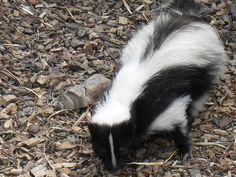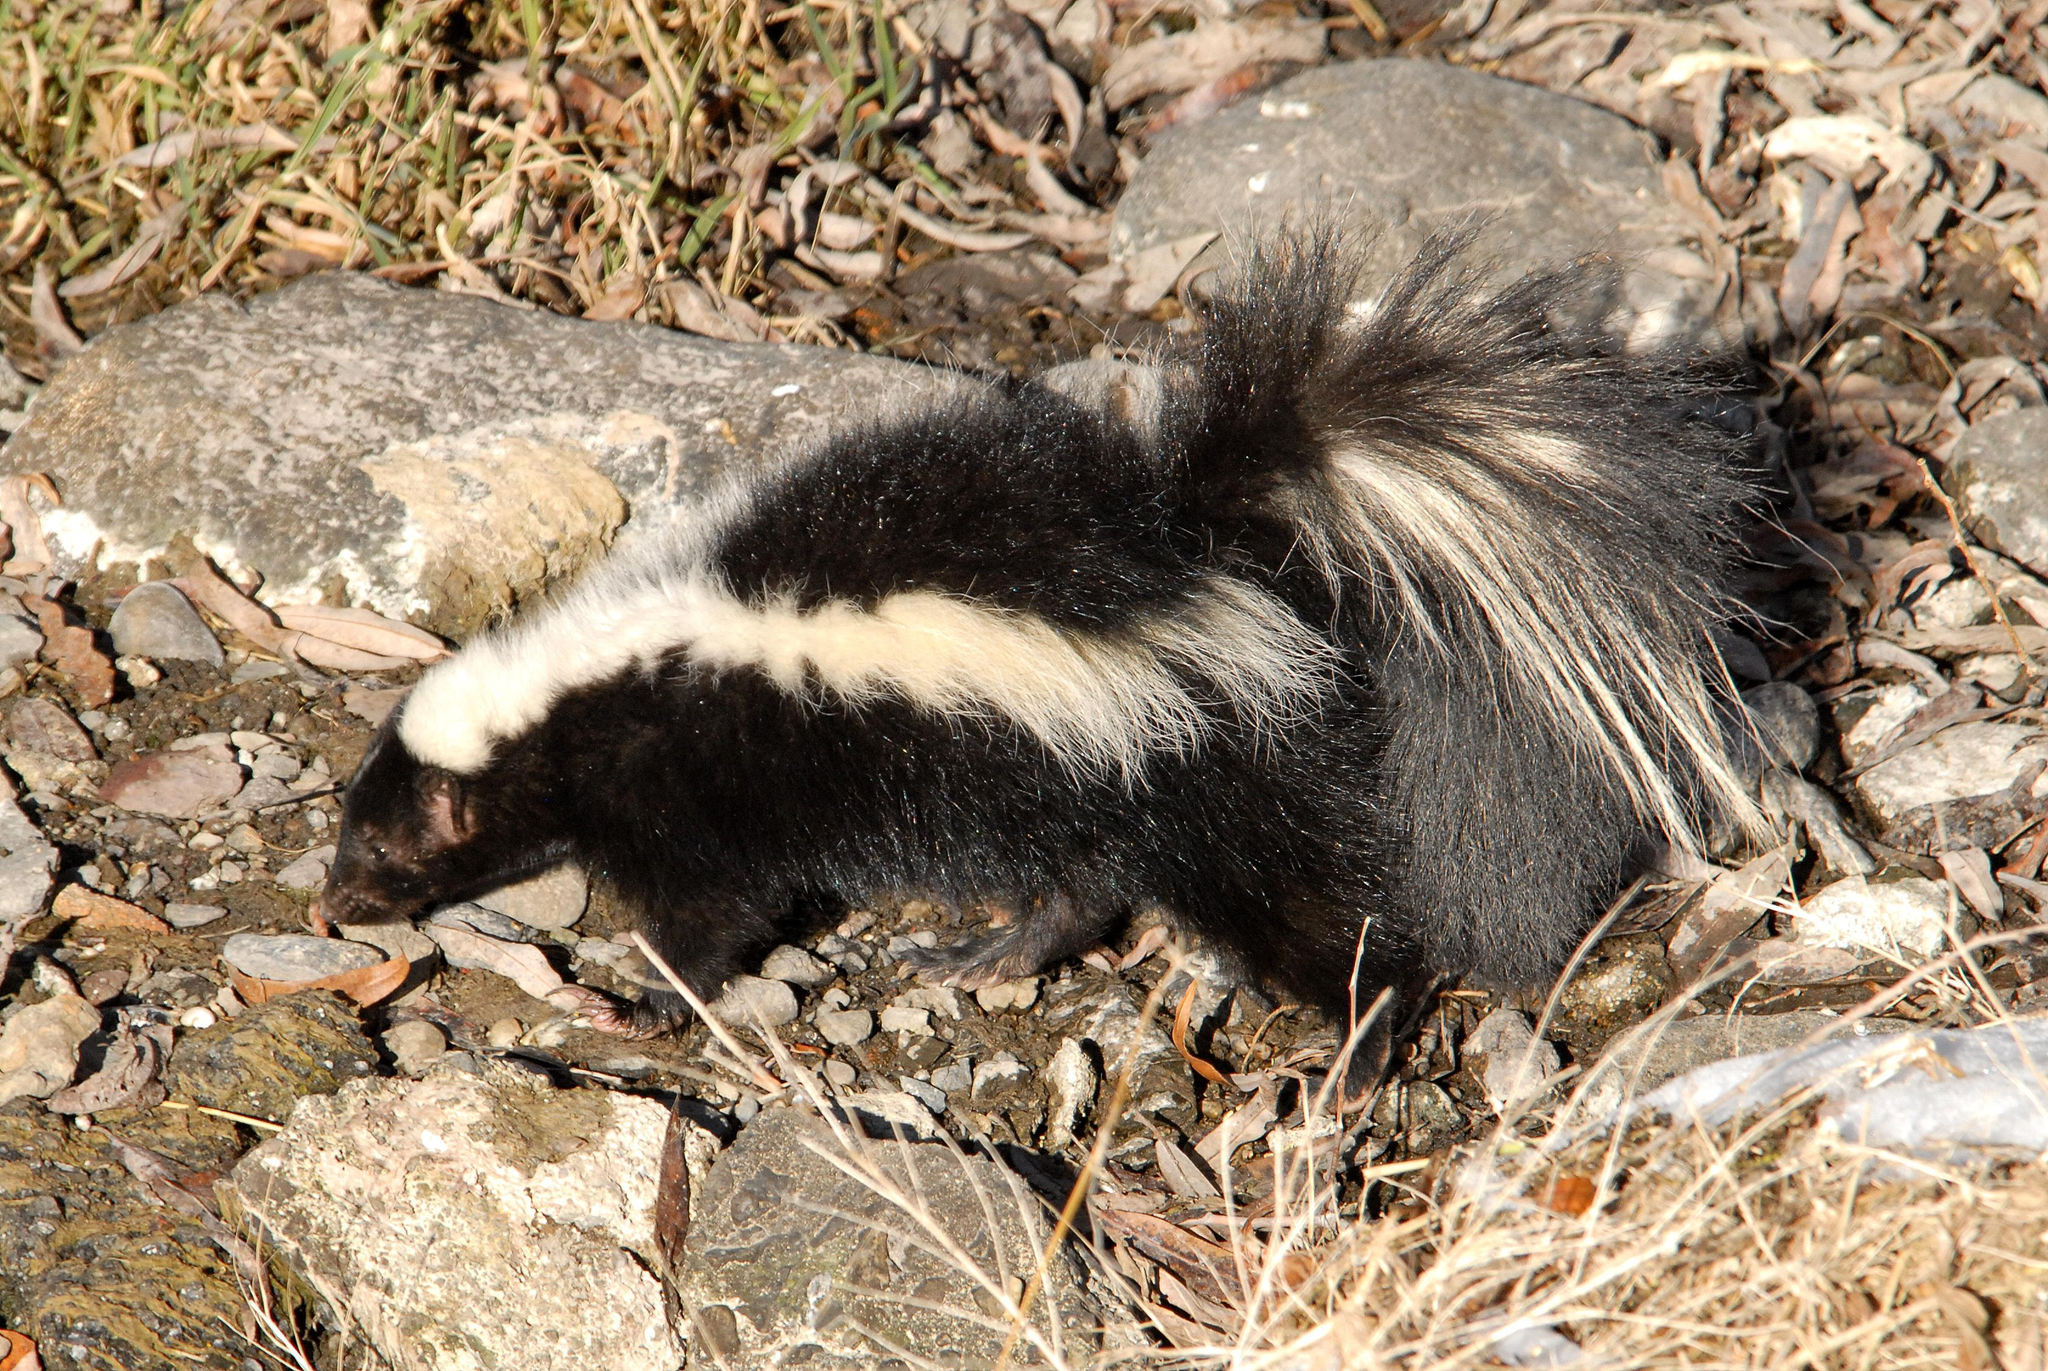The first image is the image on the left, the second image is the image on the right. Examine the images to the left and right. Is the description "The left image features at least one skunk with a bold white stripe that starts at its head, and the right image features a skunk with more random and numerous stripes." accurate? Answer yes or no. No. 